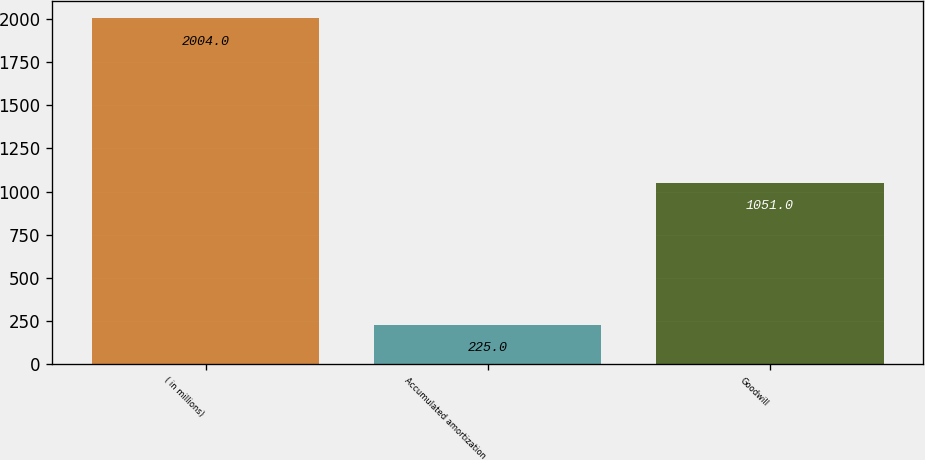Convert chart. <chart><loc_0><loc_0><loc_500><loc_500><bar_chart><fcel>( in millions)<fcel>Accumulated amortization<fcel>Goodwill<nl><fcel>2004<fcel>225<fcel>1051<nl></chart> 